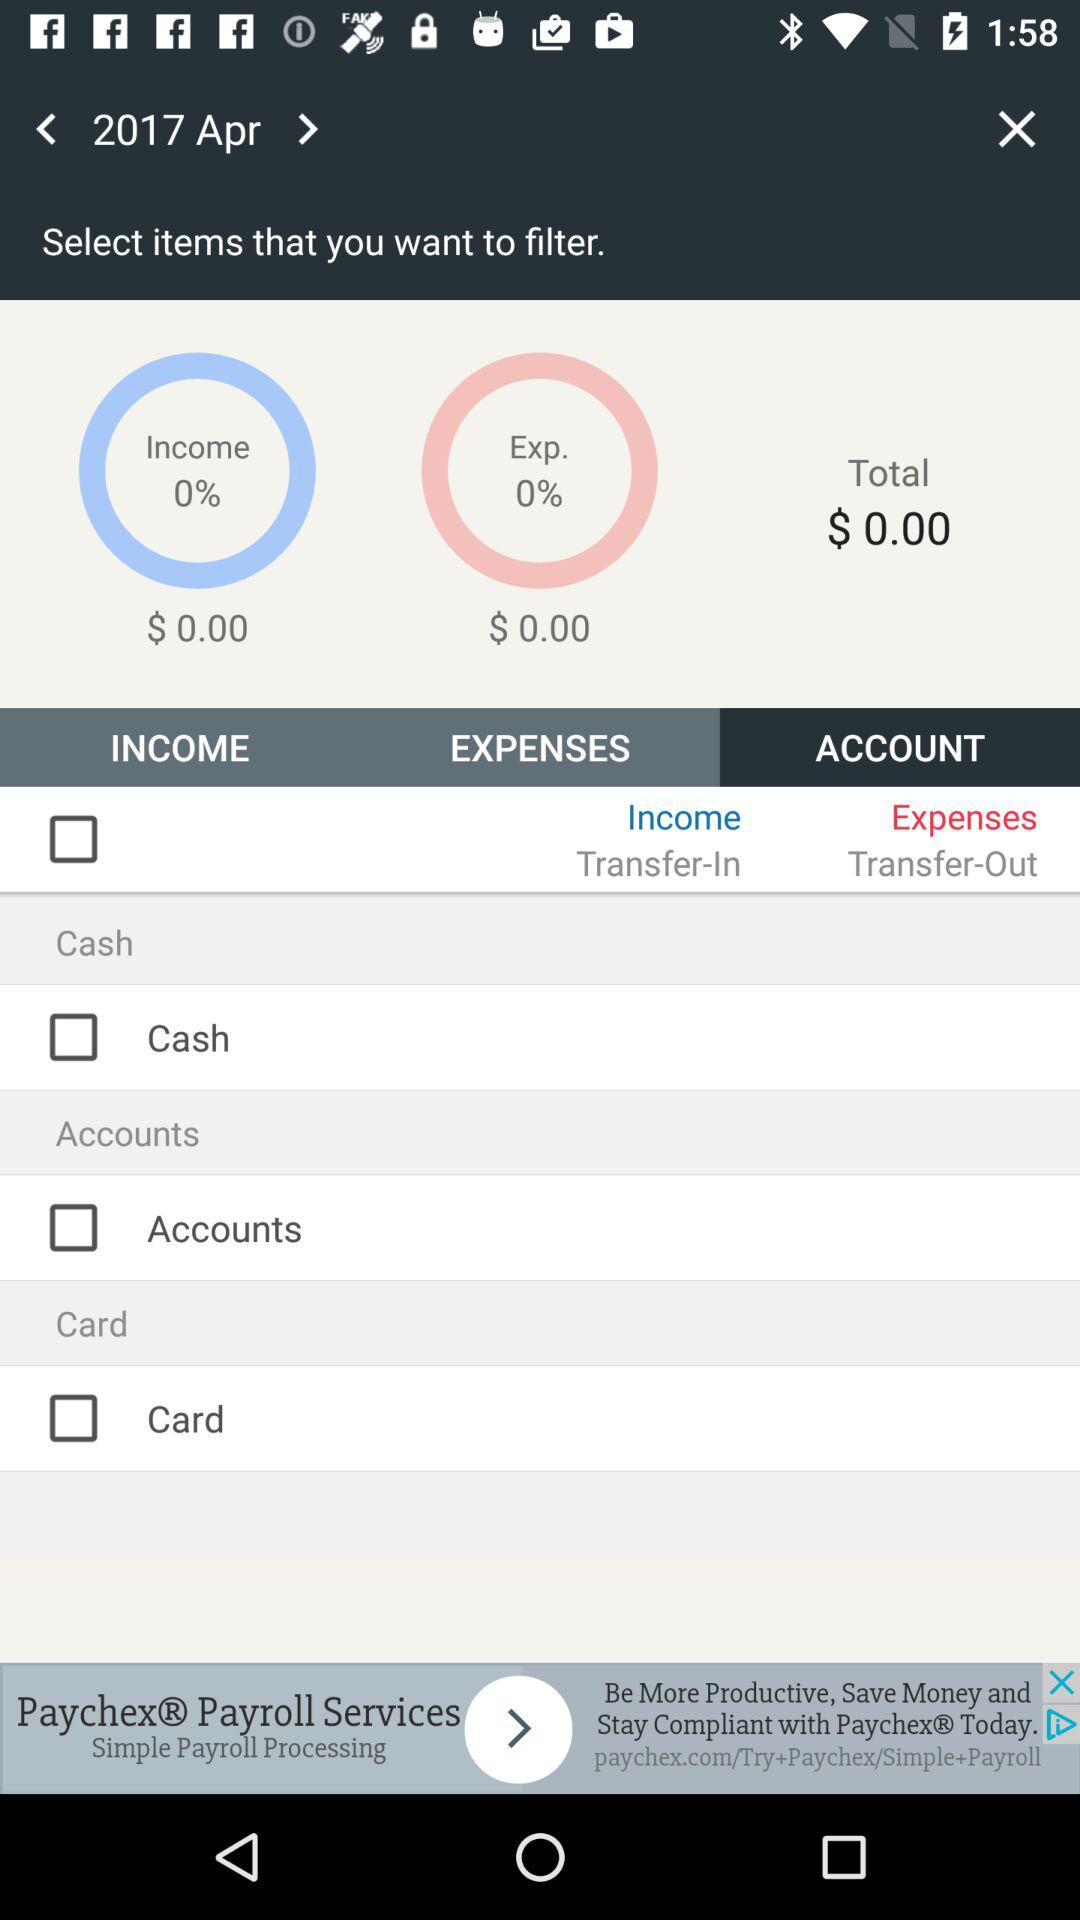What is the status of "Cash"? The status is "off". 